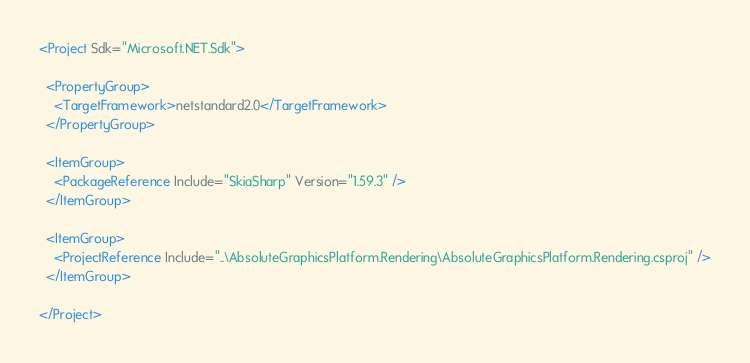Convert code to text. <code><loc_0><loc_0><loc_500><loc_500><_XML_><Project Sdk="Microsoft.NET.Sdk">

  <PropertyGroup>
    <TargetFramework>netstandard2.0</TargetFramework>
  </PropertyGroup>

  <ItemGroup>
    <PackageReference Include="SkiaSharp" Version="1.59.3" />
  </ItemGroup>

  <ItemGroup>
    <ProjectReference Include="..\AbsoluteGraphicsPlatform.Rendering\AbsoluteGraphicsPlatform.Rendering.csproj" />
  </ItemGroup>

</Project>
</code> 